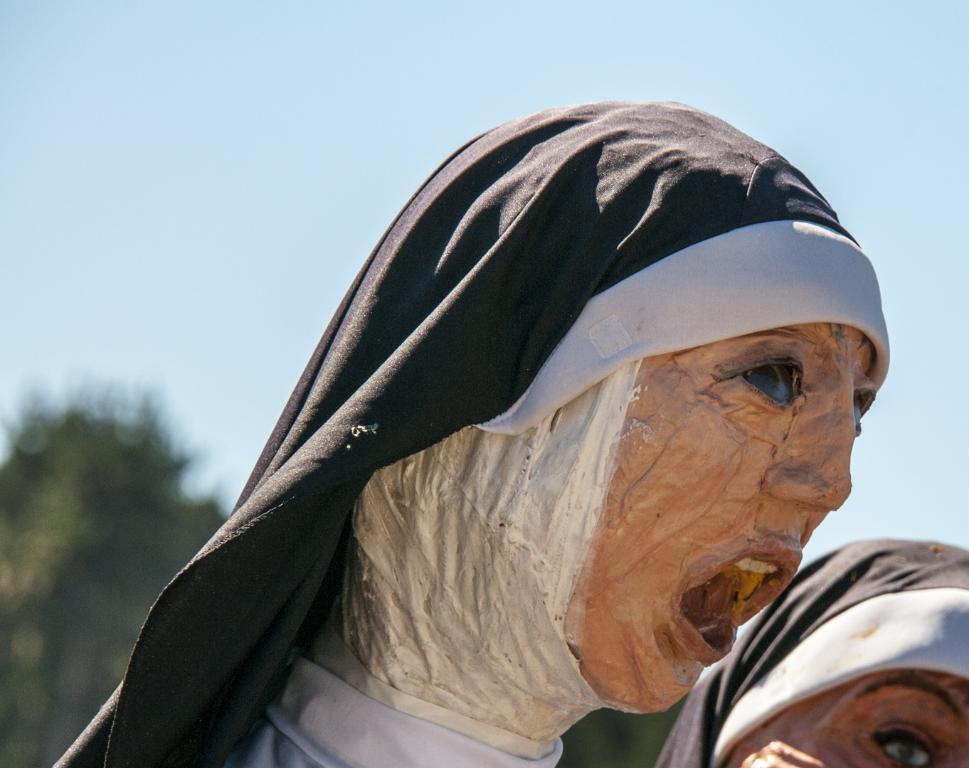What can be seen in the image that resembles people? There are statues of two people in the image. What type of natural environment is visible in the background of the image? There are trees visible in the background of the image. What is visible at the top of the image? The sky is visible at the top of the image. What type of polish is being applied to the statues in the image? There is no indication in the image that any polish is being applied to the statues. 